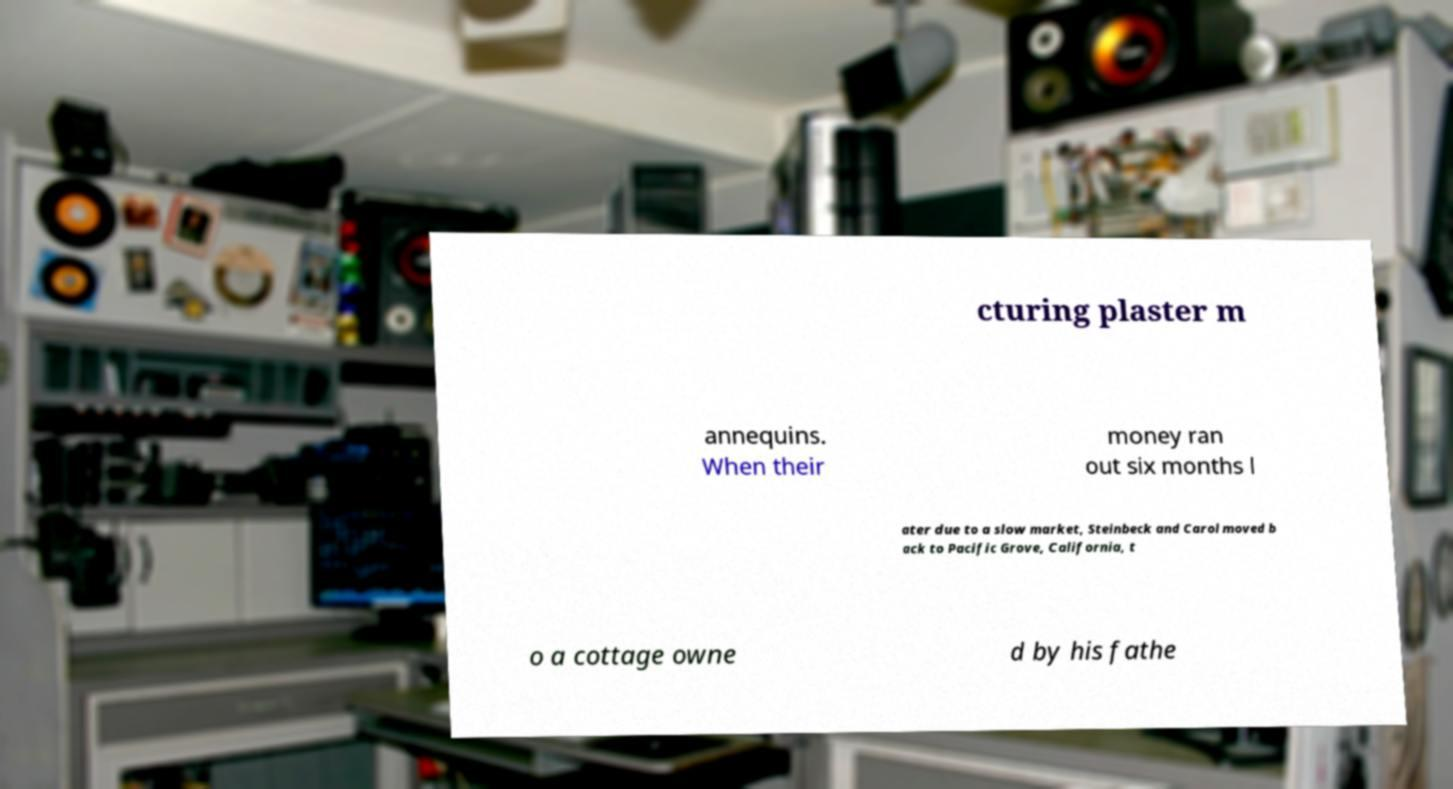There's text embedded in this image that I need extracted. Can you transcribe it verbatim? cturing plaster m annequins. When their money ran out six months l ater due to a slow market, Steinbeck and Carol moved b ack to Pacific Grove, California, t o a cottage owne d by his fathe 